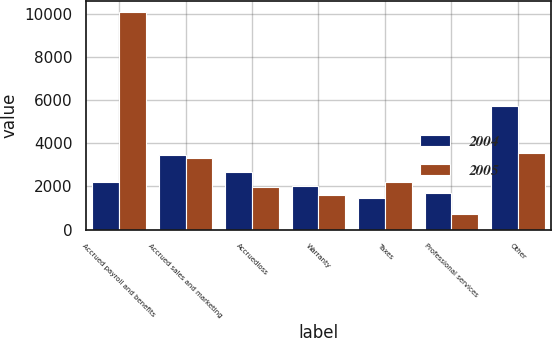<chart> <loc_0><loc_0><loc_500><loc_500><stacked_bar_chart><ecel><fcel>Accrued payroll and benefits<fcel>Accrued sales and marketing<fcel>Accruedloss<fcel>Warranty<fcel>Taxes<fcel>Professional services<fcel>Other<nl><fcel>2004<fcel>2201<fcel>3437<fcel>2681<fcel>1998<fcel>1483<fcel>1713<fcel>5730<nl><fcel>2005<fcel>10090<fcel>3313<fcel>1985<fcel>1616<fcel>2201<fcel>745<fcel>3531<nl></chart> 